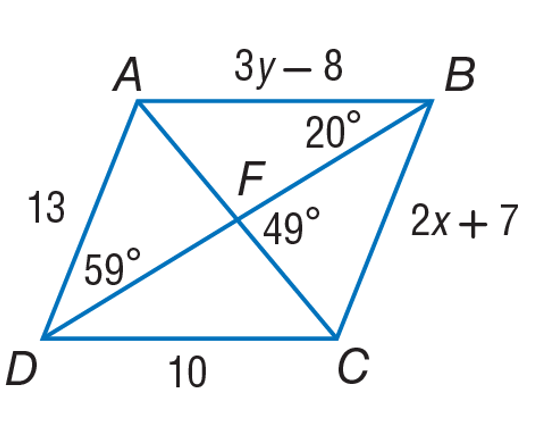Answer the mathemtical geometry problem and directly provide the correct option letter.
Question: Use parallelogram A B C D to find m \angle D A C.
Choices: A: 54 B: 59 C: 72 D: 108 C 